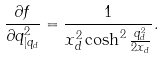<formula> <loc_0><loc_0><loc_500><loc_500>\frac { \partial f } { \partial q ^ { 2 } _ { | q _ { d } } } = \frac { 1 } { x _ { d } ^ { 2 } \cosh ^ { 2 } \frac { q _ { d } ^ { 2 } } { 2 x _ { d } } } .</formula> 